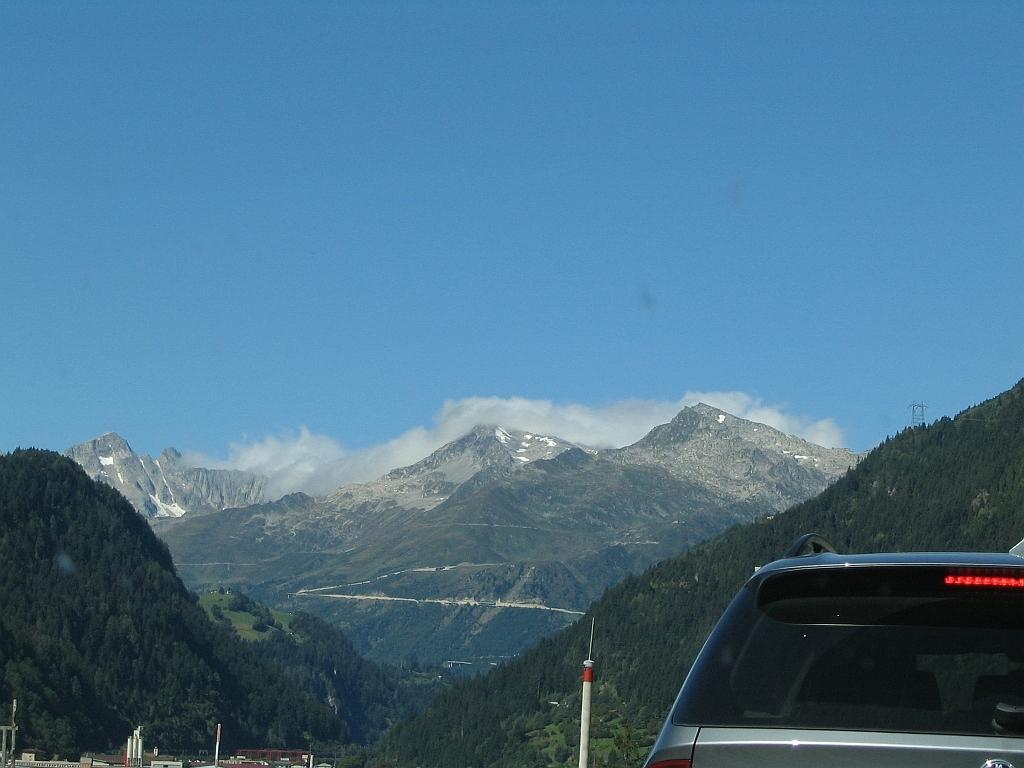Describe this image in one or two sentences. In this picture we can see a car on the right side. There are few poles. Some greenery is visible from left to right. There are mountains in the background. Sky is blue in color and cloudy. 